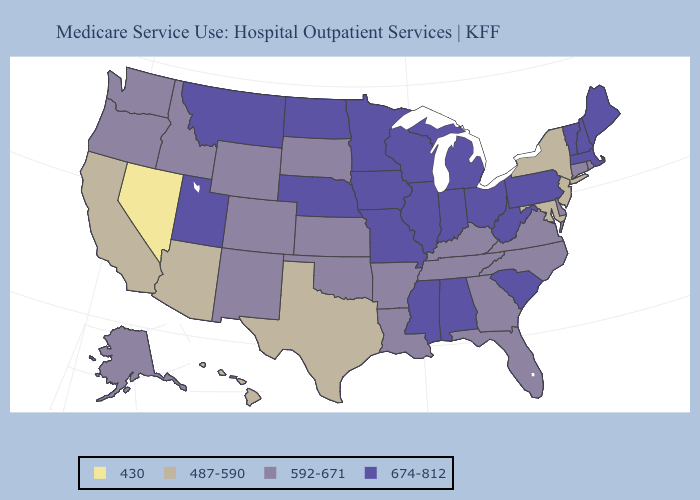What is the value of West Virginia?
Give a very brief answer. 674-812. Does Louisiana have the lowest value in the South?
Give a very brief answer. No. Does the map have missing data?
Concise answer only. No. What is the lowest value in the Northeast?
Quick response, please. 487-590. Does Vermont have the highest value in the Northeast?
Short answer required. Yes. What is the highest value in the USA?
Quick response, please. 674-812. What is the value of Florida?
Answer briefly. 592-671. Among the states that border New Mexico , which have the lowest value?
Short answer required. Arizona, Texas. Does West Virginia have the highest value in the South?
Write a very short answer. Yes. Does Colorado have the highest value in the West?
Be succinct. No. What is the value of North Dakota?
Write a very short answer. 674-812. Does Ohio have the lowest value in the MidWest?
Give a very brief answer. No. Does New Hampshire have a higher value than Montana?
Give a very brief answer. No. Does California have a higher value than Nevada?
Give a very brief answer. Yes. Name the states that have a value in the range 674-812?
Quick response, please. Alabama, Illinois, Indiana, Iowa, Maine, Massachusetts, Michigan, Minnesota, Mississippi, Missouri, Montana, Nebraska, New Hampshire, North Dakota, Ohio, Pennsylvania, South Carolina, Utah, Vermont, West Virginia, Wisconsin. 